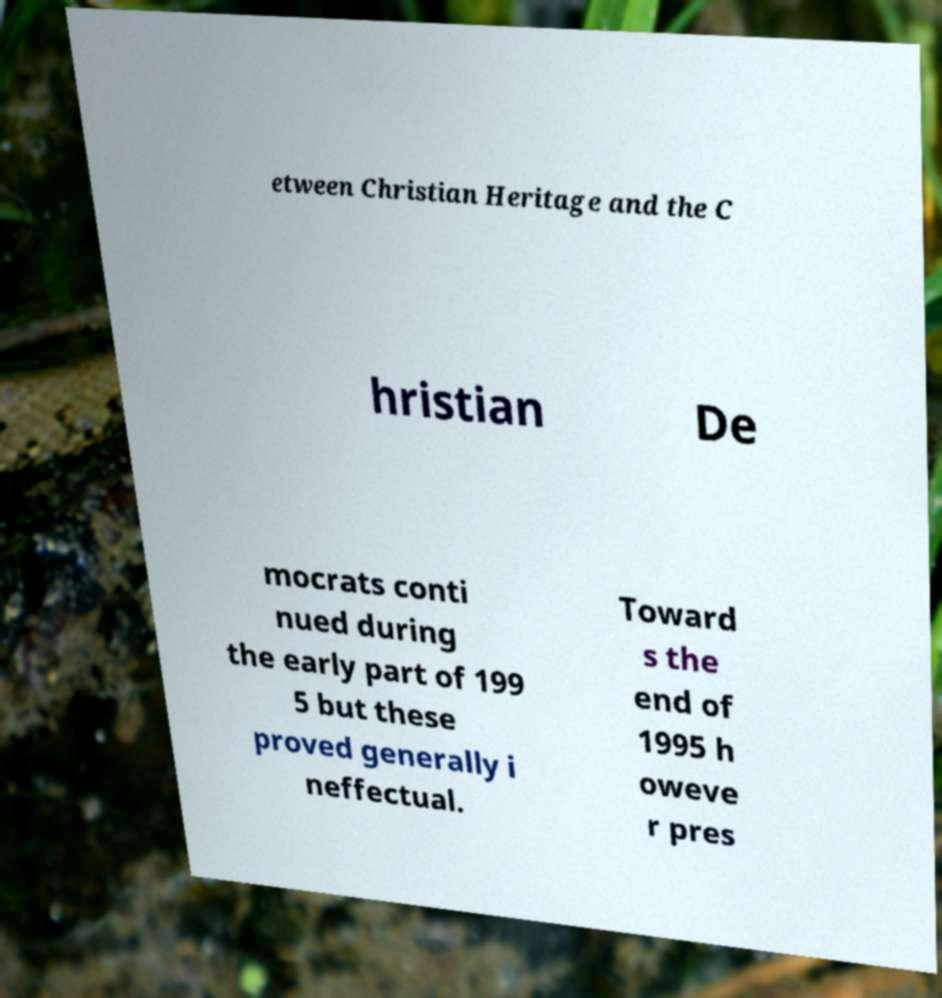For documentation purposes, I need the text within this image transcribed. Could you provide that? etween Christian Heritage and the C hristian De mocrats conti nued during the early part of 199 5 but these proved generally i neffectual. Toward s the end of 1995 h oweve r pres 